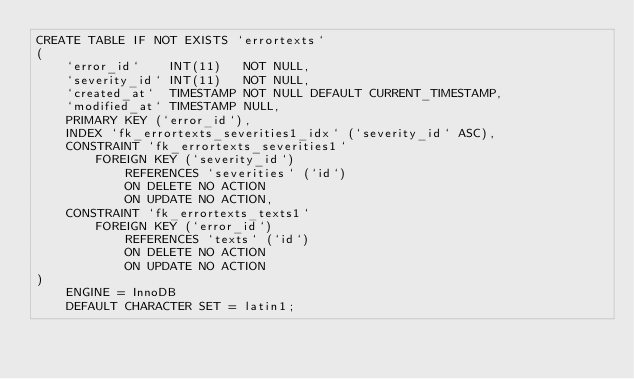<code> <loc_0><loc_0><loc_500><loc_500><_SQL_>CREATE TABLE IF NOT EXISTS `errortexts`
(
    `error_id`    INT(11)   NOT NULL,
    `severity_id` INT(11)   NOT NULL,
    `created_at`  TIMESTAMP NOT NULL DEFAULT CURRENT_TIMESTAMP,
    `modified_at` TIMESTAMP NULL,
    PRIMARY KEY (`error_id`),
    INDEX `fk_errortexts_severities1_idx` (`severity_id` ASC),
    CONSTRAINT `fk_errortexts_severities1`
        FOREIGN KEY (`severity_id`)
            REFERENCES `severities` (`id`)
            ON DELETE NO ACTION
            ON UPDATE NO ACTION,
    CONSTRAINT `fk_errortexts_texts1`
        FOREIGN KEY (`error_id`)
            REFERENCES `texts` (`id`)
            ON DELETE NO ACTION
            ON UPDATE NO ACTION
)
    ENGINE = InnoDB
    DEFAULT CHARACTER SET = latin1;</code> 